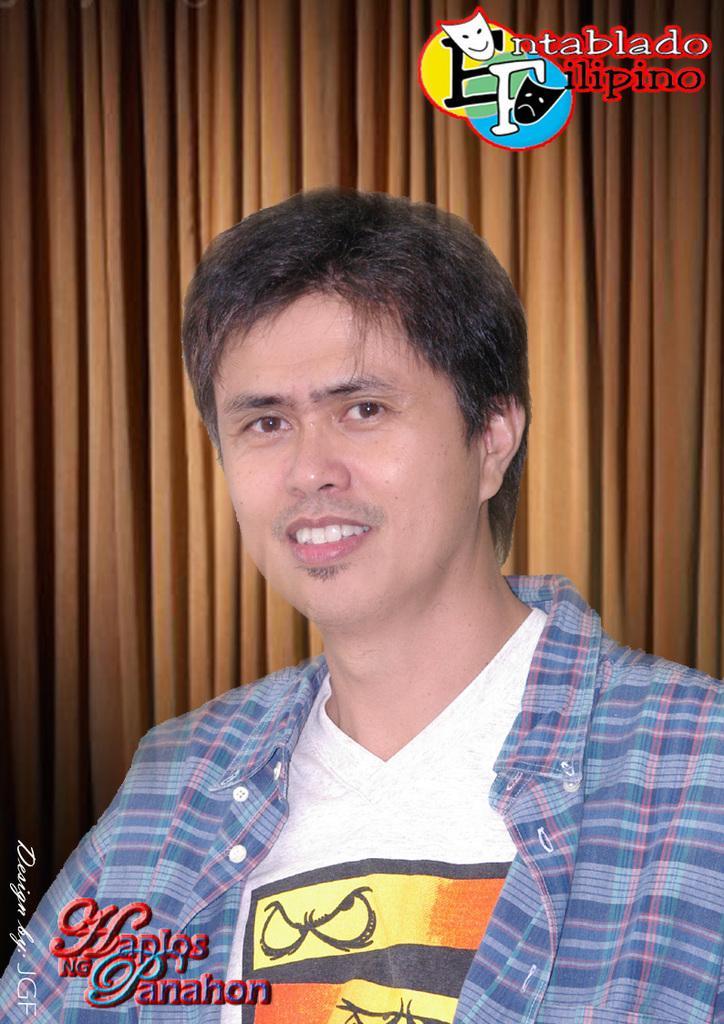How would you summarize this image in a sentence or two? On the bottom left, there is a watermark. In the middle of this image, there is a person in a white color T-shirt, smiling. On the top right, there is a watermark. In the background, there is a brown color curtain. 